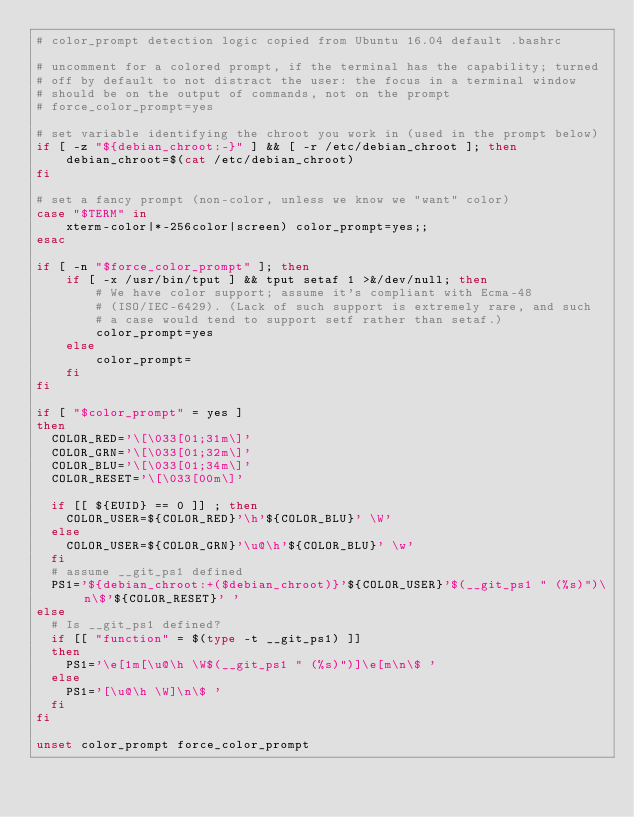Convert code to text. <code><loc_0><loc_0><loc_500><loc_500><_Bash_># color_prompt detection logic copied from Ubuntu 16.04 default .bashrc

# uncomment for a colored prompt, if the terminal has the capability; turned
# off by default to not distract the user: the focus in a terminal window
# should be on the output of commands, not on the prompt
# force_color_prompt=yes

# set variable identifying the chroot you work in (used in the prompt below)
if [ -z "${debian_chroot:-}" ] && [ -r /etc/debian_chroot ]; then
    debian_chroot=$(cat /etc/debian_chroot)
fi

# set a fancy prompt (non-color, unless we know we "want" color)
case "$TERM" in
    xterm-color|*-256color|screen) color_prompt=yes;;
esac

if [ -n "$force_color_prompt" ]; then
    if [ -x /usr/bin/tput ] && tput setaf 1 >&/dev/null; then
        # We have color support; assume it's compliant with Ecma-48
        # (ISO/IEC-6429). (Lack of such support is extremely rare, and such
        # a case would tend to support setf rather than setaf.)
        color_prompt=yes
    else
        color_prompt=
    fi
fi

if [ "$color_prompt" = yes ]
then
  COLOR_RED='\[\033[01;31m\]'
  COLOR_GRN='\[\033[01;32m\]'
  COLOR_BLU='\[\033[01;34m\]'
  COLOR_RESET='\[\033[00m\]'

  if [[ ${EUID} == 0 ]] ; then
    COLOR_USER=${COLOR_RED}'\h'${COLOR_BLU}' \W'
  else
    COLOR_USER=${COLOR_GRN}'\u@\h'${COLOR_BLU}' \w'
  fi
  # assume __git_ps1 defined
  PS1='${debian_chroot:+($debian_chroot)}'${COLOR_USER}'$(__git_ps1 " (%s)")\n\$'${COLOR_RESET}' '
else
  # Is __git_ps1 defined?
  if [[ "function" = $(type -t __git_ps1) ]]
  then
    PS1='\e[1m[\u@\h \W$(__git_ps1 " (%s)")]\e[m\n\$ '
  else
    PS1='[\u@\h \W]\n\$ '
  fi
fi

unset color_prompt force_color_prompt

</code> 